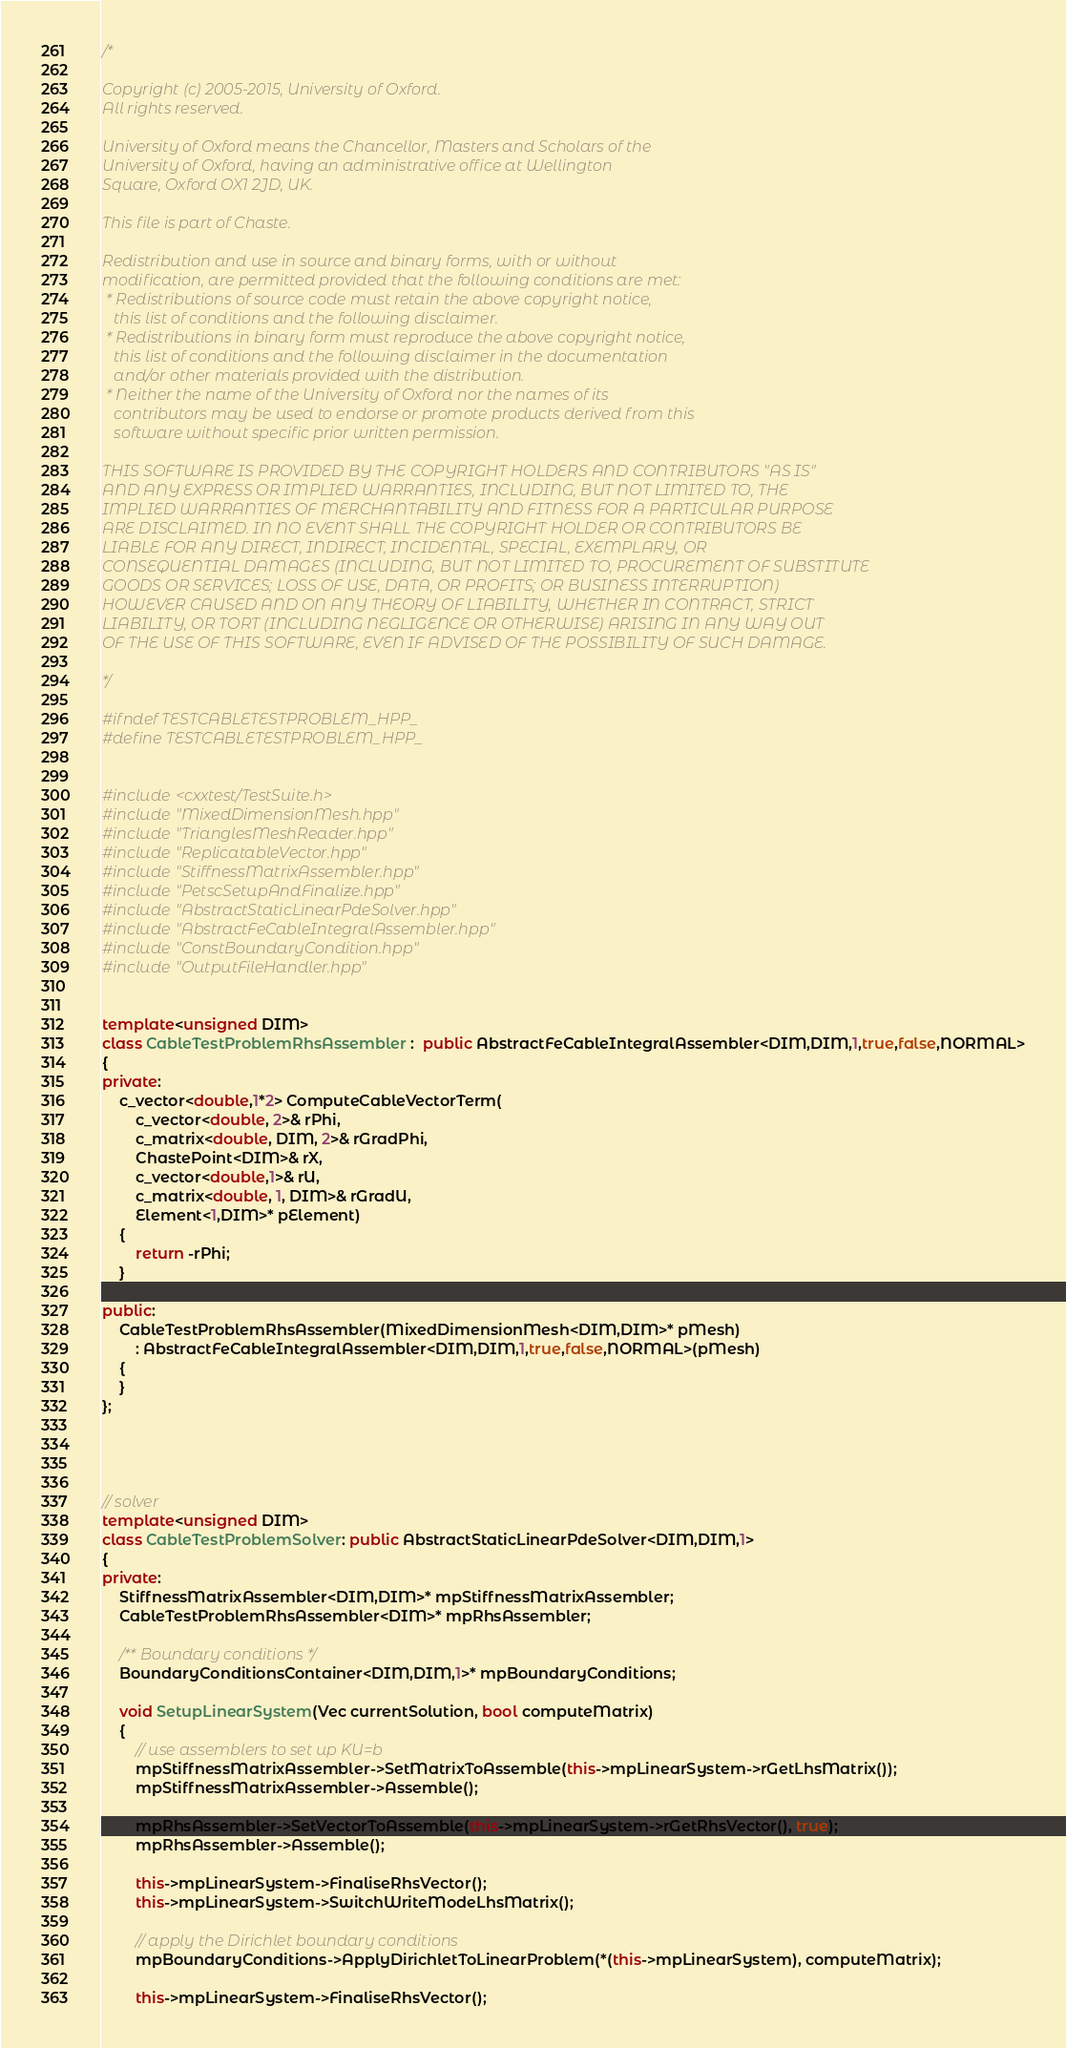<code> <loc_0><loc_0><loc_500><loc_500><_C++_>/*

Copyright (c) 2005-2015, University of Oxford.
All rights reserved.

University of Oxford means the Chancellor, Masters and Scholars of the
University of Oxford, having an administrative office at Wellington
Square, Oxford OX1 2JD, UK.

This file is part of Chaste.

Redistribution and use in source and binary forms, with or without
modification, are permitted provided that the following conditions are met:
 * Redistributions of source code must retain the above copyright notice,
   this list of conditions and the following disclaimer.
 * Redistributions in binary form must reproduce the above copyright notice,
   this list of conditions and the following disclaimer in the documentation
   and/or other materials provided with the distribution.
 * Neither the name of the University of Oxford nor the names of its
   contributors may be used to endorse or promote products derived from this
   software without specific prior written permission.

THIS SOFTWARE IS PROVIDED BY THE COPYRIGHT HOLDERS AND CONTRIBUTORS "AS IS"
AND ANY EXPRESS OR IMPLIED WARRANTIES, INCLUDING, BUT NOT LIMITED TO, THE
IMPLIED WARRANTIES OF MERCHANTABILITY AND FITNESS FOR A PARTICULAR PURPOSE
ARE DISCLAIMED. IN NO EVENT SHALL THE COPYRIGHT HOLDER OR CONTRIBUTORS BE
LIABLE FOR ANY DIRECT, INDIRECT, INCIDENTAL, SPECIAL, EXEMPLARY, OR
CONSEQUENTIAL DAMAGES (INCLUDING, BUT NOT LIMITED TO, PROCUREMENT OF SUBSTITUTE
GOODS OR SERVICES; LOSS OF USE, DATA, OR PROFITS; OR BUSINESS INTERRUPTION)
HOWEVER CAUSED AND ON ANY THEORY OF LIABILITY, WHETHER IN CONTRACT, STRICT
LIABILITY, OR TORT (INCLUDING NEGLIGENCE OR OTHERWISE) ARISING IN ANY WAY OUT
OF THE USE OF THIS SOFTWARE, EVEN IF ADVISED OF THE POSSIBILITY OF SUCH DAMAGE.

*/

#ifndef TESTCABLETESTPROBLEM_HPP_
#define TESTCABLETESTPROBLEM_HPP_


#include <cxxtest/TestSuite.h>
#include "MixedDimensionMesh.hpp"
#include "TrianglesMeshReader.hpp"
#include "ReplicatableVector.hpp"
#include "StiffnessMatrixAssembler.hpp"
#include "PetscSetupAndFinalize.hpp"
#include "AbstractStaticLinearPdeSolver.hpp"
#include "AbstractFeCableIntegralAssembler.hpp"
#include "ConstBoundaryCondition.hpp"
#include "OutputFileHandler.hpp"


template<unsigned DIM>
class CableTestProblemRhsAssembler :  public AbstractFeCableIntegralAssembler<DIM,DIM,1,true,false,NORMAL>
{
private:
    c_vector<double,1*2> ComputeCableVectorTerm(
        c_vector<double, 2>& rPhi,
        c_matrix<double, DIM, 2>& rGradPhi,
        ChastePoint<DIM>& rX,
        c_vector<double,1>& rU,
        c_matrix<double, 1, DIM>& rGradU,
        Element<1,DIM>* pElement)
    {
        return -rPhi;
    }

public:
    CableTestProblemRhsAssembler(MixedDimensionMesh<DIM,DIM>* pMesh)
        : AbstractFeCableIntegralAssembler<DIM,DIM,1,true,false,NORMAL>(pMesh)
    {
    }
};




// solver
template<unsigned DIM>
class CableTestProblemSolver: public AbstractStaticLinearPdeSolver<DIM,DIM,1>
{
private:
    StiffnessMatrixAssembler<DIM,DIM>* mpStiffnessMatrixAssembler;
    CableTestProblemRhsAssembler<DIM>* mpRhsAssembler;

    /** Boundary conditions */
    BoundaryConditionsContainer<DIM,DIM,1>* mpBoundaryConditions;

    void SetupLinearSystem(Vec currentSolution, bool computeMatrix)
    {
        // use assemblers to set up KU=b
        mpStiffnessMatrixAssembler->SetMatrixToAssemble(this->mpLinearSystem->rGetLhsMatrix());
        mpStiffnessMatrixAssembler->Assemble();

        mpRhsAssembler->SetVectorToAssemble(this->mpLinearSystem->rGetRhsVector(), true);
        mpRhsAssembler->Assemble();

        this->mpLinearSystem->FinaliseRhsVector();
        this->mpLinearSystem->SwitchWriteModeLhsMatrix();

        // apply the Dirichlet boundary conditions
        mpBoundaryConditions->ApplyDirichletToLinearProblem(*(this->mpLinearSystem), computeMatrix);

        this->mpLinearSystem->FinaliseRhsVector();</code> 